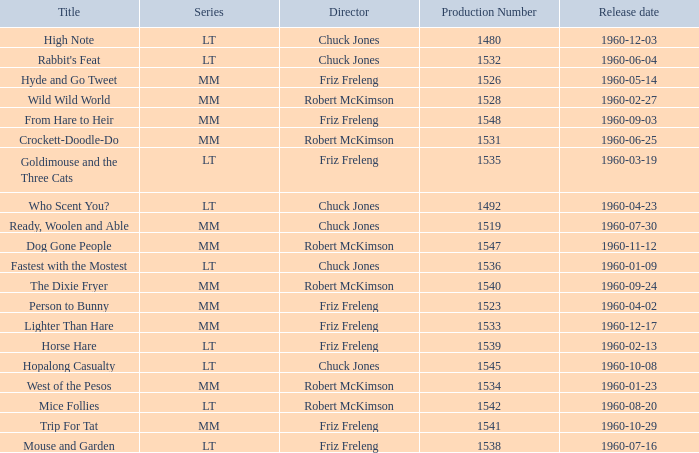What is the Series number of the episode with a production number of 1547? MM. 